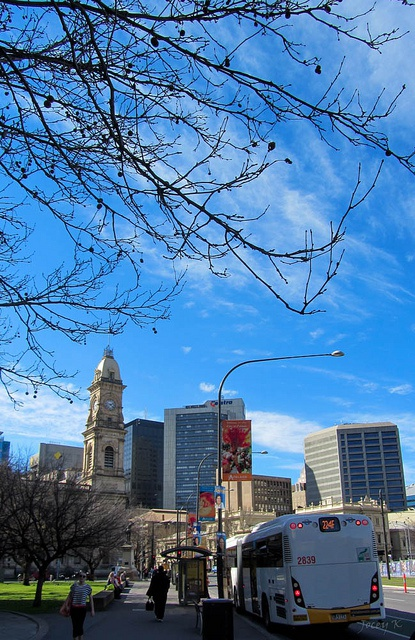Describe the objects in this image and their specific colors. I can see bus in black, blue, and gray tones, people in black, navy, gray, and darkblue tones, people in black and gray tones, bench in black, gray, and darkgray tones, and people in black, gray, purple, and darkgray tones in this image. 